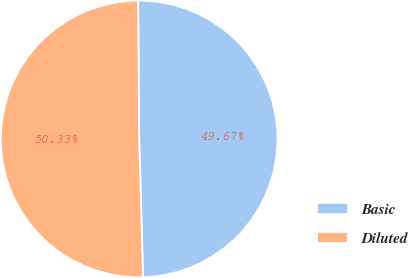Convert chart. <chart><loc_0><loc_0><loc_500><loc_500><pie_chart><fcel>Basic<fcel>Diluted<nl><fcel>49.67%<fcel>50.33%<nl></chart> 